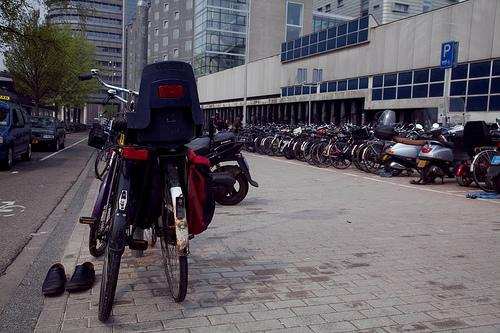State the predominant color theme featured in the image. The predominant color theme in the image is a combination of gray, black, and blue. Mention the people present in the image and their actions, if any. There are no people visible in the image. Highlight any two buildings in the image along with their unique features. There is a building with a light gray facade and large windows, and another building with a similar modern design featuring a row of windows and a blue sign. Mention any three noticeable objects in the image along with their colors. A pair of black shoes are on the street, a red and black bag is on a bike, and a blue parking sign is visible in the background. Pick one object from the image and describe its material or texture. The tire of the bike is made of rubber and is black in color. Describe any activity or interaction happening between the objects in the image. There is no activity or interaction happening between the objects, as everything seems to be parked or stationary in the image. List down the types of roads and their materials visible in the image. There's a paved brick road and a dark gray asphalt road on the scene. What types of vehicles can be spotted in the image? Mention their colors, if possible. A blue-colored taxi, a dark-colored car, a small gray motorbike, and a small red motorbike can be seen in the image. Briefly describe the scene involving the bicycle and its surroundings. A bicycle with a baby seat is parked on a brick-paved street, casting a shadow, with a backpack on it and a pair of shoes nearby. 